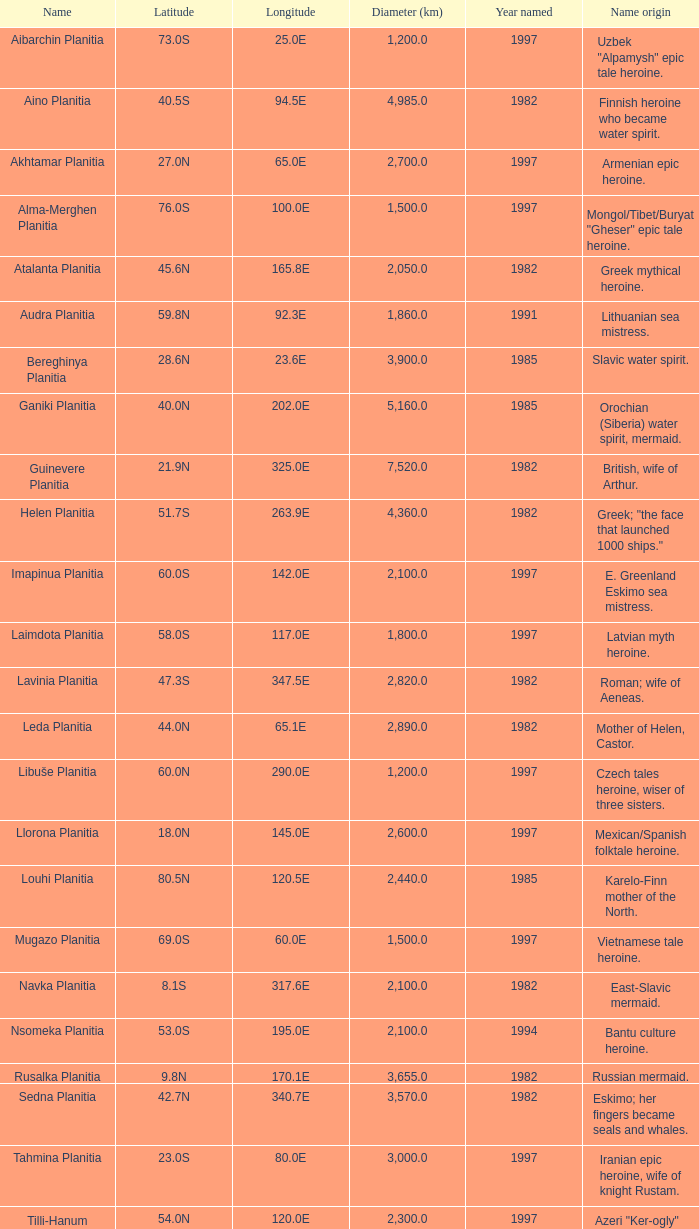What's the name origin of feature of diameter (km) 2,155.0 Karelo-Finn mermaid. 